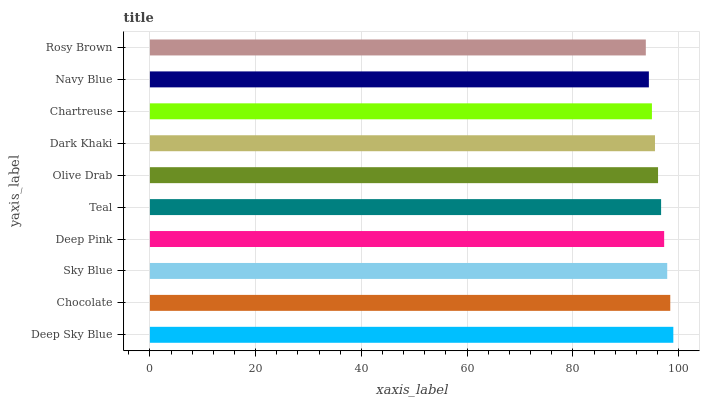Is Rosy Brown the minimum?
Answer yes or no. Yes. Is Deep Sky Blue the maximum?
Answer yes or no. Yes. Is Chocolate the minimum?
Answer yes or no. No. Is Chocolate the maximum?
Answer yes or no. No. Is Deep Sky Blue greater than Chocolate?
Answer yes or no. Yes. Is Chocolate less than Deep Sky Blue?
Answer yes or no. Yes. Is Chocolate greater than Deep Sky Blue?
Answer yes or no. No. Is Deep Sky Blue less than Chocolate?
Answer yes or no. No. Is Teal the high median?
Answer yes or no. Yes. Is Olive Drab the low median?
Answer yes or no. Yes. Is Rosy Brown the high median?
Answer yes or no. No. Is Sky Blue the low median?
Answer yes or no. No. 